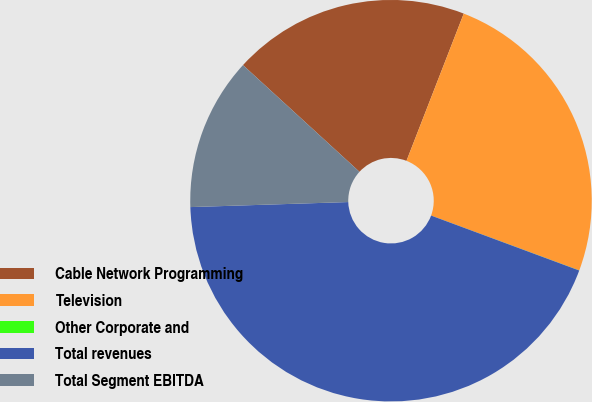<chart> <loc_0><loc_0><loc_500><loc_500><pie_chart><fcel>Cable Network Programming<fcel>Television<fcel>Other Corporate and<fcel>Total revenues<fcel>Total Segment EBITDA<nl><fcel>19.1%<fcel>24.74%<fcel>0.01%<fcel>43.84%<fcel>12.31%<nl></chart> 